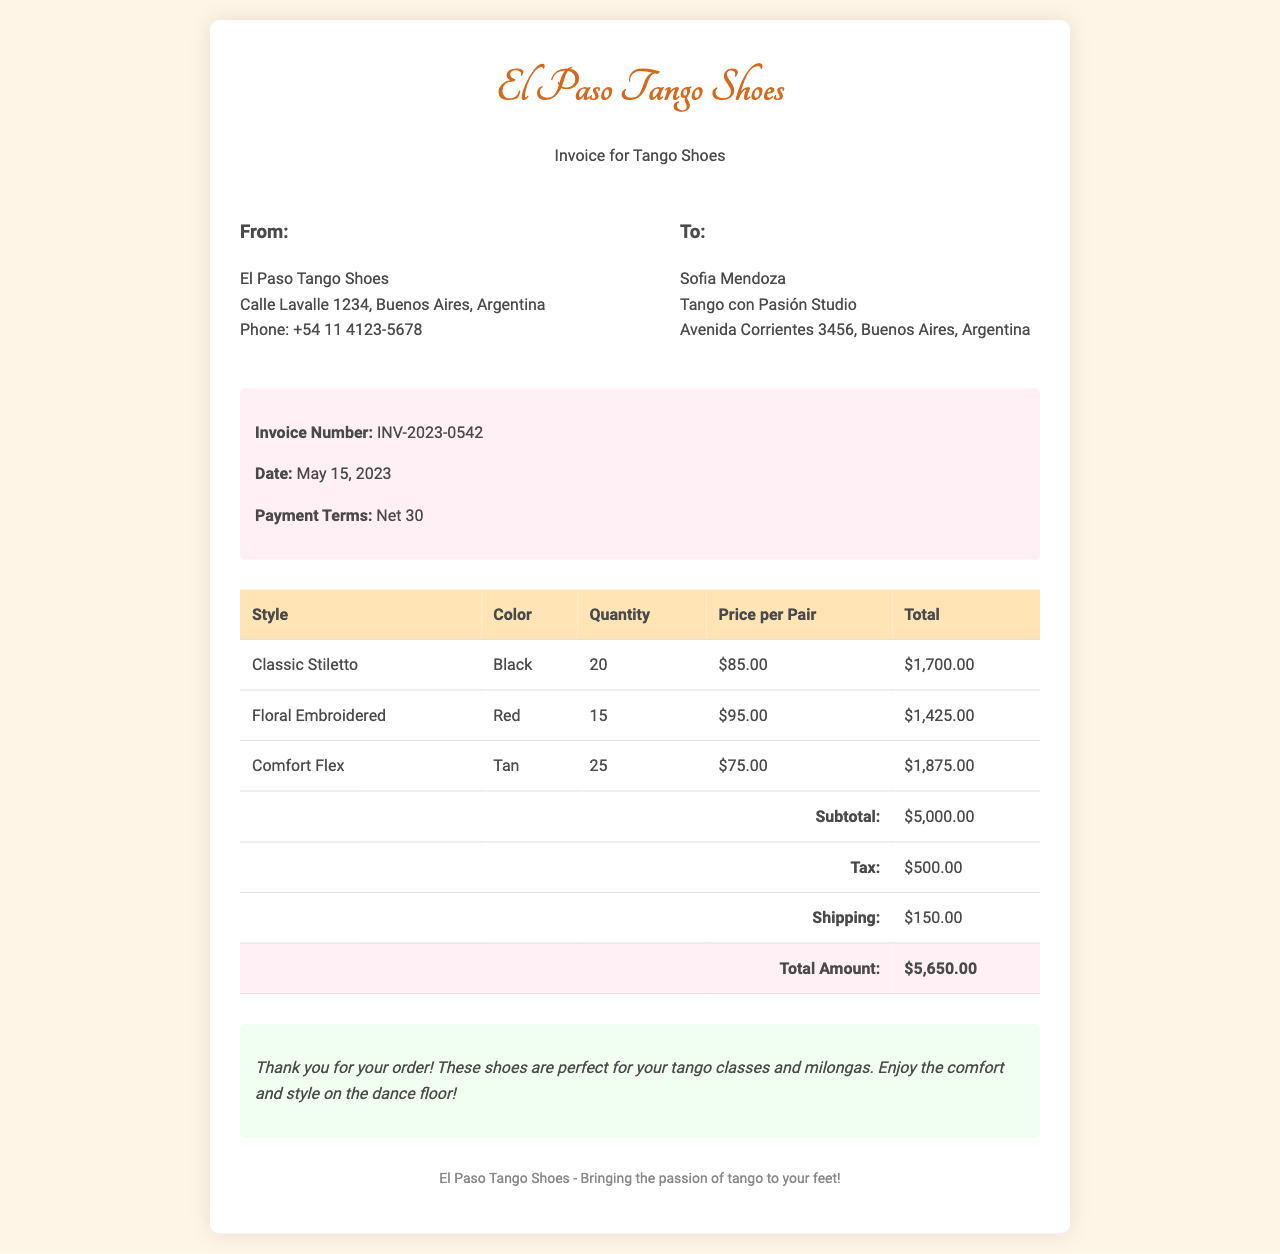What is the invoice number? The invoice number is listed in the document under the invoice details section.
Answer: INV-2023-0542 Who is the recipient of the invoice? The recipient's name appears at the top of the recipient section.
Answer: Sofia Mendoza How many pairs of Comfort Flex shoes were ordered? The quantity for Comfort Flex shoes can be found in the itemized table.
Answer: 25 What is the tax amount on the invoice? The tax amount is provided in the itemized breakdown of costs in the table.
Answer: $500.00 What is the total amount due? The total amount is calculated from the subtotal, tax, and shipping in the total row of the table.
Answer: $5,650.00 What style of shoes has the highest quantity ordered? The style with the highest quantity can be determined by comparing the quantities in the table.
Answer: Comfort Flex What color are the Floral Embroidered shoes? The color information is specified next to the style in the table.
Answer: Red What is the shipping cost? The shipping cost is detailed in the itemized section of the document.
Answer: $150.00 What is the payment term for this invoice? The payment terms are specified in the invoice details of the document.
Answer: Net 30 